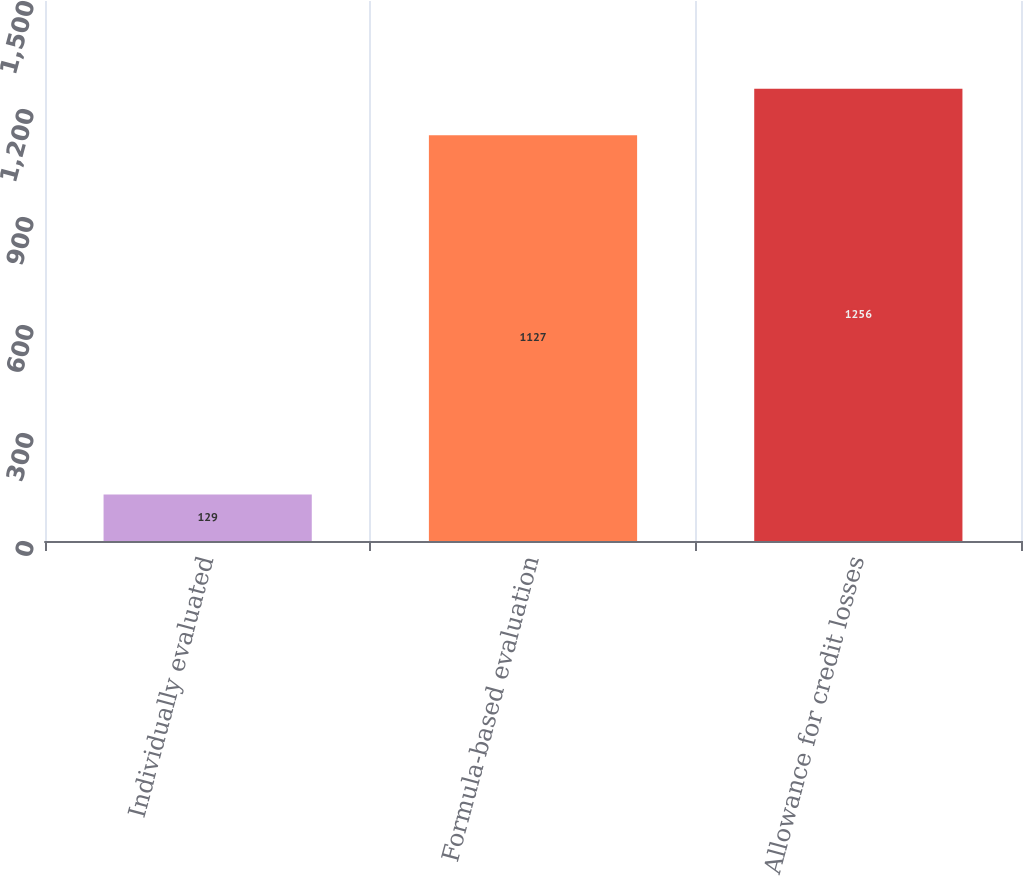Convert chart to OTSL. <chart><loc_0><loc_0><loc_500><loc_500><bar_chart><fcel>Individually evaluated<fcel>Formula-based evaluation<fcel>Allowance for credit losses<nl><fcel>129<fcel>1127<fcel>1256<nl></chart> 